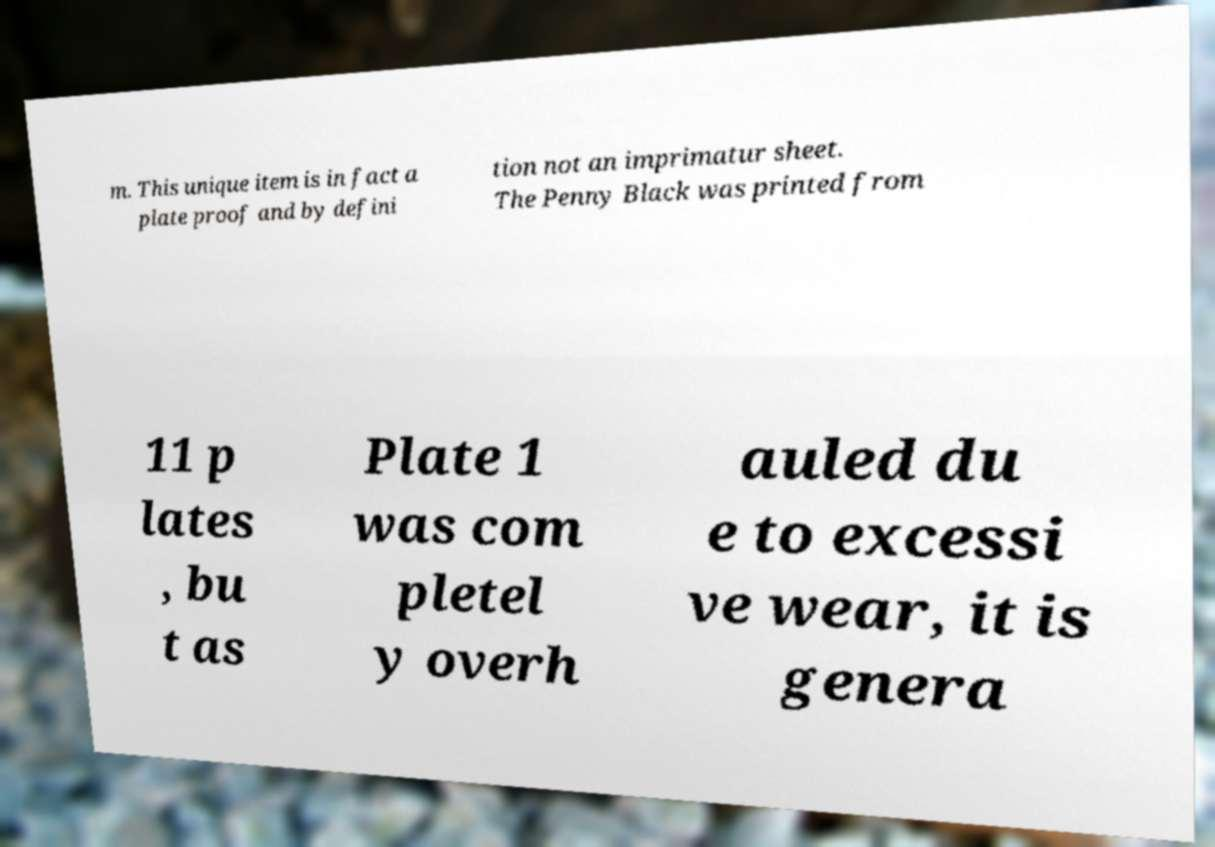Could you assist in decoding the text presented in this image and type it out clearly? m. This unique item is in fact a plate proof and by defini tion not an imprimatur sheet. The Penny Black was printed from 11 p lates , bu t as Plate 1 was com pletel y overh auled du e to excessi ve wear, it is genera 